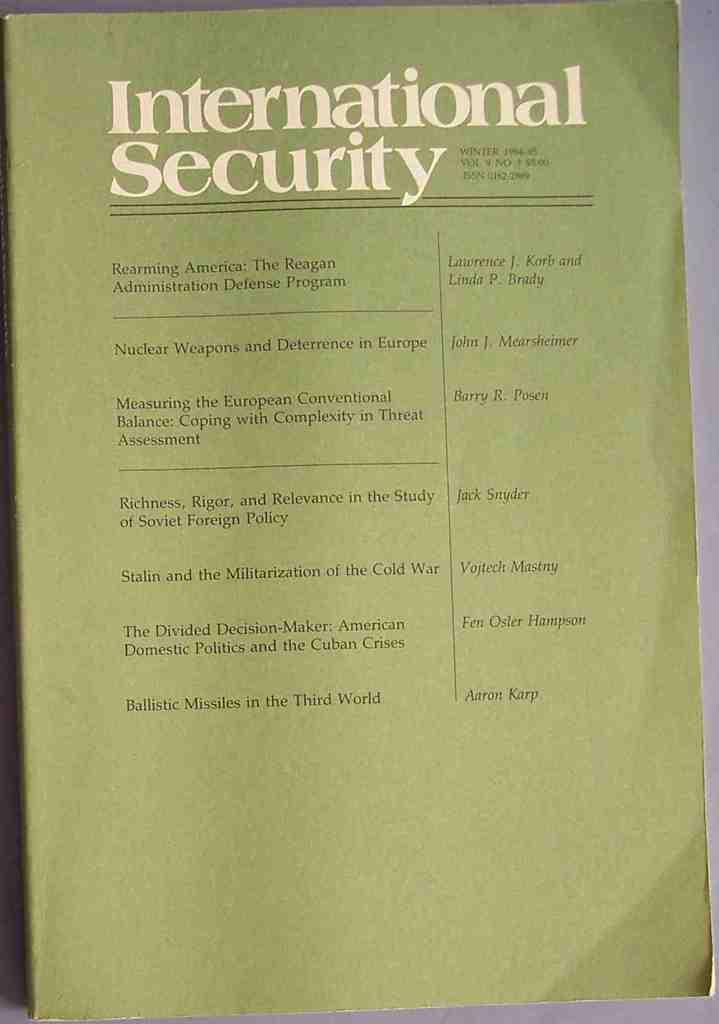<image>
Render a clear and concise summary of the photo. Volume 9 of International Security includes something written by Vojtech Mastny 